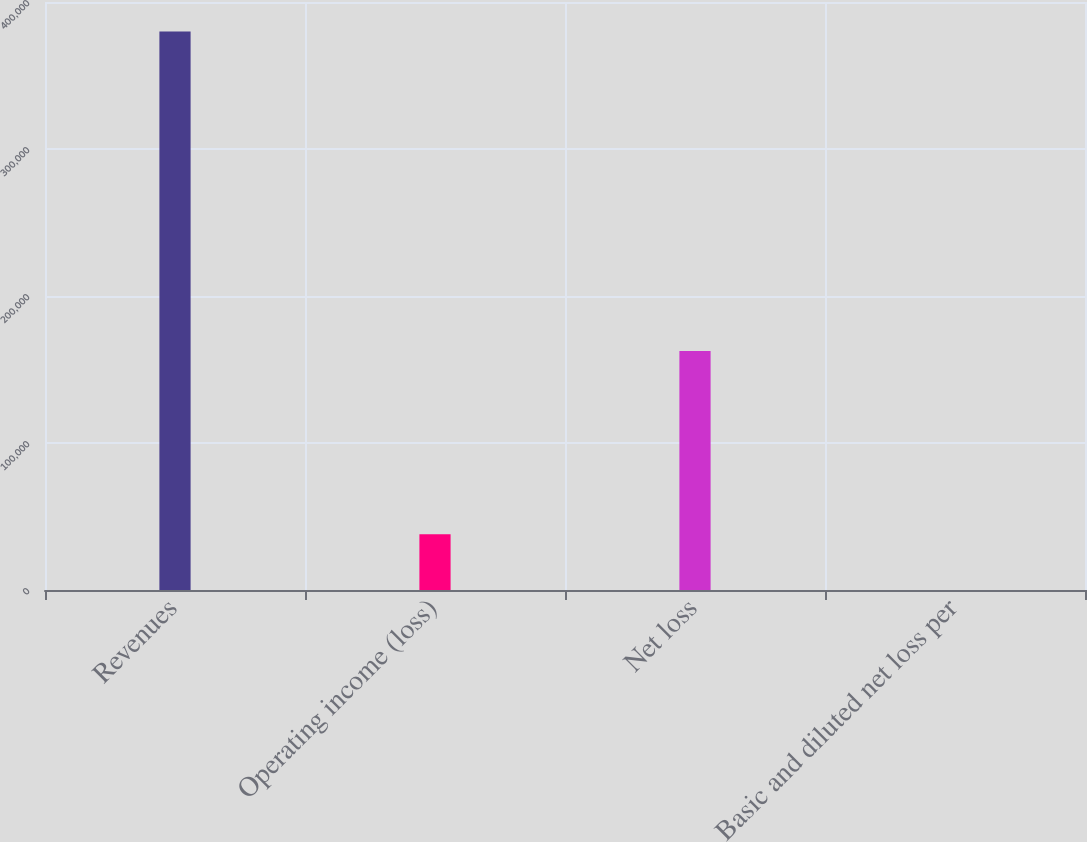<chart> <loc_0><loc_0><loc_500><loc_500><bar_chart><fcel>Revenues<fcel>Operating income (loss)<fcel>Net loss<fcel>Basic and diluted net loss per<nl><fcel>379863<fcel>37987.7<fcel>162573<fcel>1.57<nl></chart> 